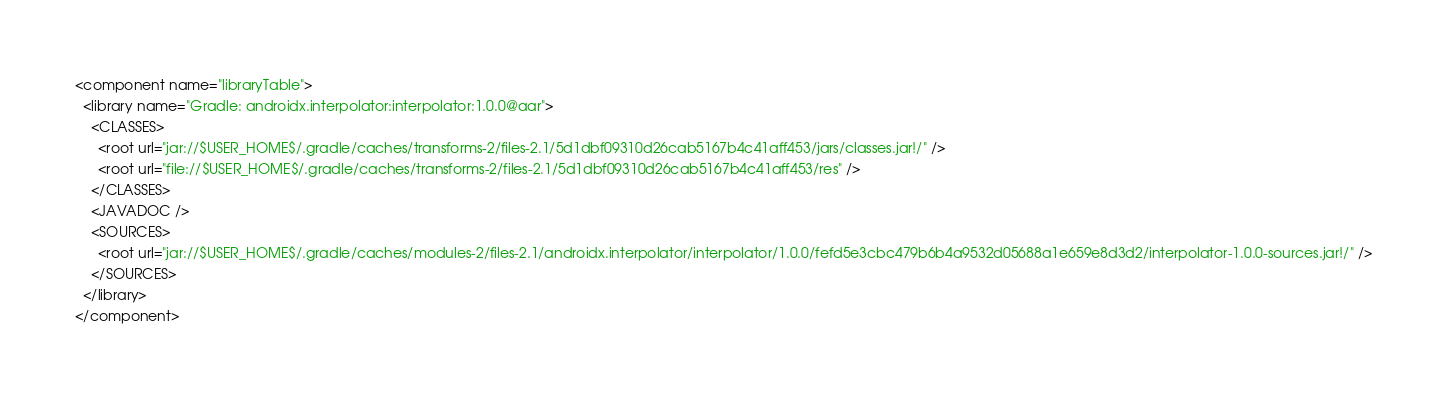<code> <loc_0><loc_0><loc_500><loc_500><_XML_><component name="libraryTable">
  <library name="Gradle: androidx.interpolator:interpolator:1.0.0@aar">
    <CLASSES>
      <root url="jar://$USER_HOME$/.gradle/caches/transforms-2/files-2.1/5d1dbf09310d26cab5167b4c41aff453/jars/classes.jar!/" />
      <root url="file://$USER_HOME$/.gradle/caches/transforms-2/files-2.1/5d1dbf09310d26cab5167b4c41aff453/res" />
    </CLASSES>
    <JAVADOC />
    <SOURCES>
      <root url="jar://$USER_HOME$/.gradle/caches/modules-2/files-2.1/androidx.interpolator/interpolator/1.0.0/fefd5e3cbc479b6b4a9532d05688a1e659e8d3d2/interpolator-1.0.0-sources.jar!/" />
    </SOURCES>
  </library>
</component></code> 